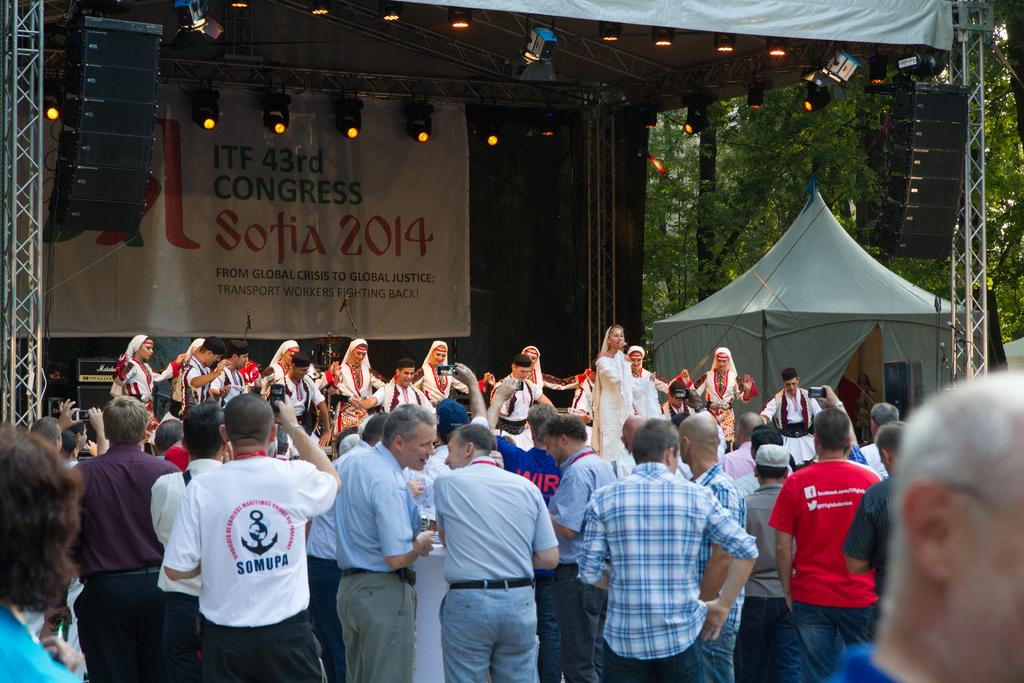Who or what can be seen in the image? There are people in the image. What structure is visible in the background? There is a tent in the background. What equipment is present in the background? Focusing lights and speakers are visible in the background. What type of signage is present in the background? There is a hoarding in the background. What type of natural elements are present in the background? Trees are present in the background. What type of shirt is the person wearing in the image? There is no information about the type of shirt the person is wearing in the image. What fictional character is present in the image? There is no fictional character present in the image; it features real people. 